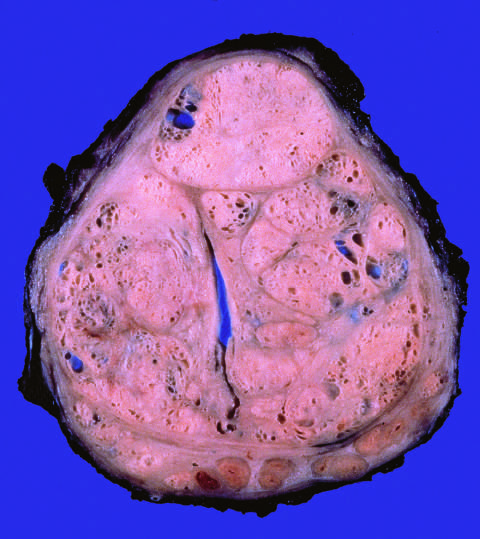do well-defined nodules compress the urethra into a slitlike lumen?
Answer the question using a single word or phrase. Yes 